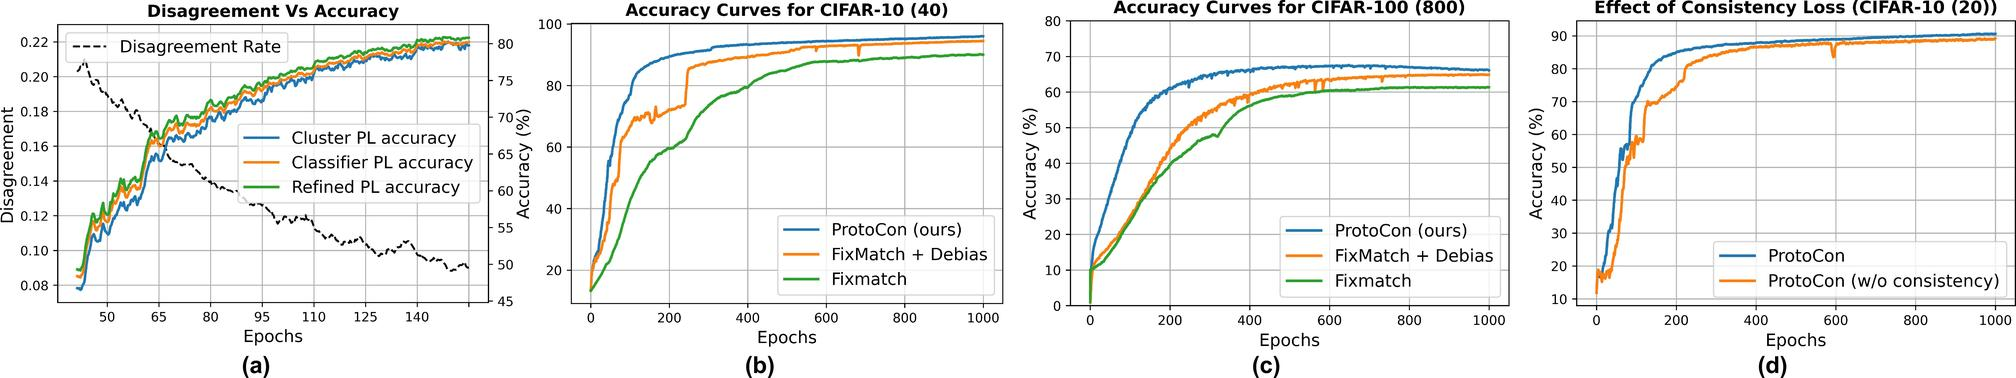What could be the cause for the initial spike in disagreement shown in Figure (a) around the 50th epoch? The initial spike in the Disagreement Rate around the 50th epoch seen in figure (a) might be due to adjustments or updates in the model's learning parameters or due to the introduction of more complex data samples at this stage. This period of adjustment results in higher disagreement, which stabilizes as the model learns and optimizes further. 